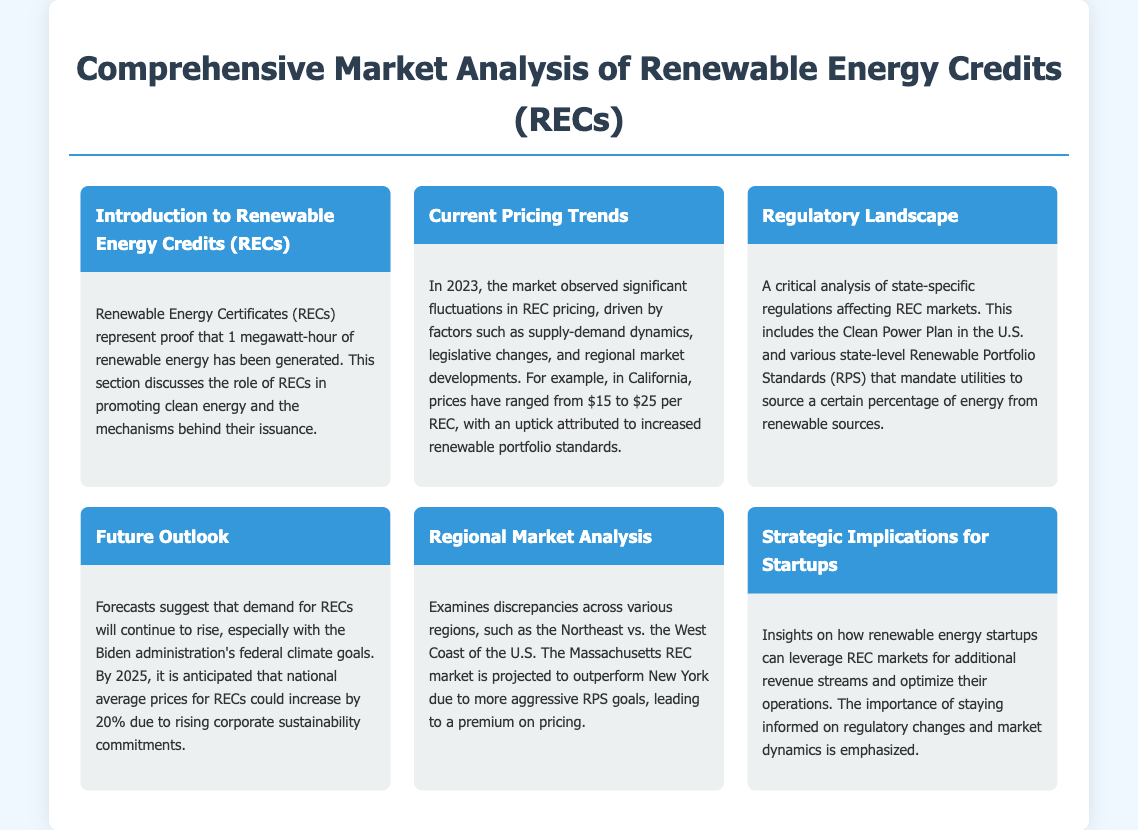What are Renewable Energy Certificates (RECs)? RECs represent proof that 1 megawatt-hour of renewable energy has been generated.
Answer: Proof that 1 megawatt-hour of renewable energy has been generated What was the price range of RECs in California in 2023? The document states that prices have ranged from $15 to $25 per REC in California in 2023.
Answer: $15 to $25 What does RPS stand for? RPS is mentioned in the context of state-level Renewable Portfolio Standards.
Answer: Renewable Portfolio Standards What is the anticipated increase in national average prices for RECs by 2025? The document indicates an anticipated increase of 20%.
Answer: 20% Which state is projected to outperform New York in REC prices? The document suggests that the Massachusetts REC market is projected to outperform New York.
Answer: Massachusetts What federal administration's goals are expected to impact REC demand? The document refers to the Biden administration's federal climate goals.
Answer: Biden administration What kind of implications does the document discuss for startups? The section addresses strategic implications on leveraging REC markets for additional revenue streams.
Answer: Strategic implications What is highlighted as important for renewable energy startups? Staying informed on regulatory changes and market dynamics is emphasized as important.
Answer: Staying informed on regulatory changes and market dynamics What section discusses fluctuations in pricing trends? Current Pricing Trends section covers fluctuations driven by various market factors.
Answer: Current Pricing Trends 